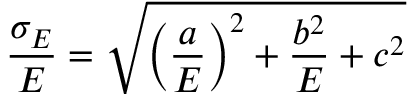<formula> <loc_0><loc_0><loc_500><loc_500>\frac { \sigma _ { E } } { E } = \sqrt { \left ( \frac { a } { E } \right ) ^ { 2 } + \frac { b ^ { 2 } } { E } + c ^ { 2 } }</formula> 